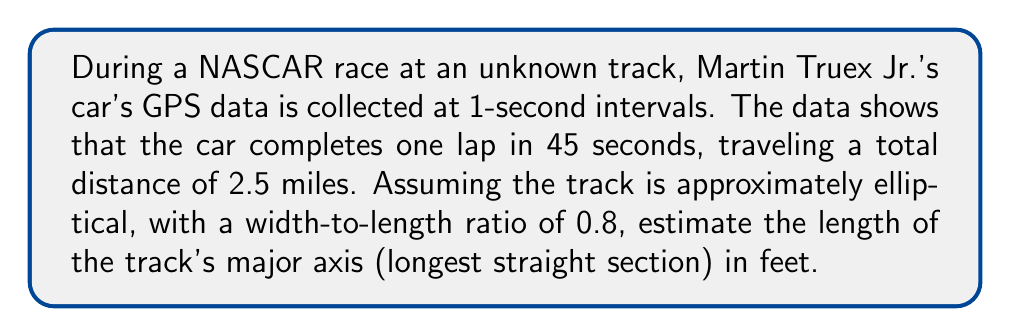Could you help me with this problem? Let's approach this step-by-step:

1) First, we need to convert the track length from miles to feet:
   $2.5 \text{ miles} \times 5280 \text{ feet/mile} = 13200 \text{ feet}$

2) For an ellipse, the circumference can be approximated using the formula:
   $C \approx \pi \sqrt{2(a^2 + b^2)}$
   where $a$ is the semi-major axis and $b$ is the semi-minor axis.

3) We're given that the width-to-length ratio is 0.8, so:
   $\frac{b}{a} = 0.8$
   $b = 0.8a$

4) Substituting into the circumference formula:
   $13200 \approx \pi \sqrt{2(a^2 + (0.8a)^2)}$
   $13200 \approx \pi \sqrt{2a^2(1 + 0.64)}$
   $13200 \approx \pi \sqrt{3.28a^2}$
   $13200 \approx \pi a \sqrt{3.28}$

5) Solving for $a$:
   $a \approx \frac{13200}{\pi \sqrt{3.28}} \approx 2309.7 \text{ feet}$

6) The major axis is twice the semi-major axis:
   $2a \approx 2 \times 2309.7 \approx 4619.4 \text{ feet}$
Answer: $4619 \text{ feet}$ 